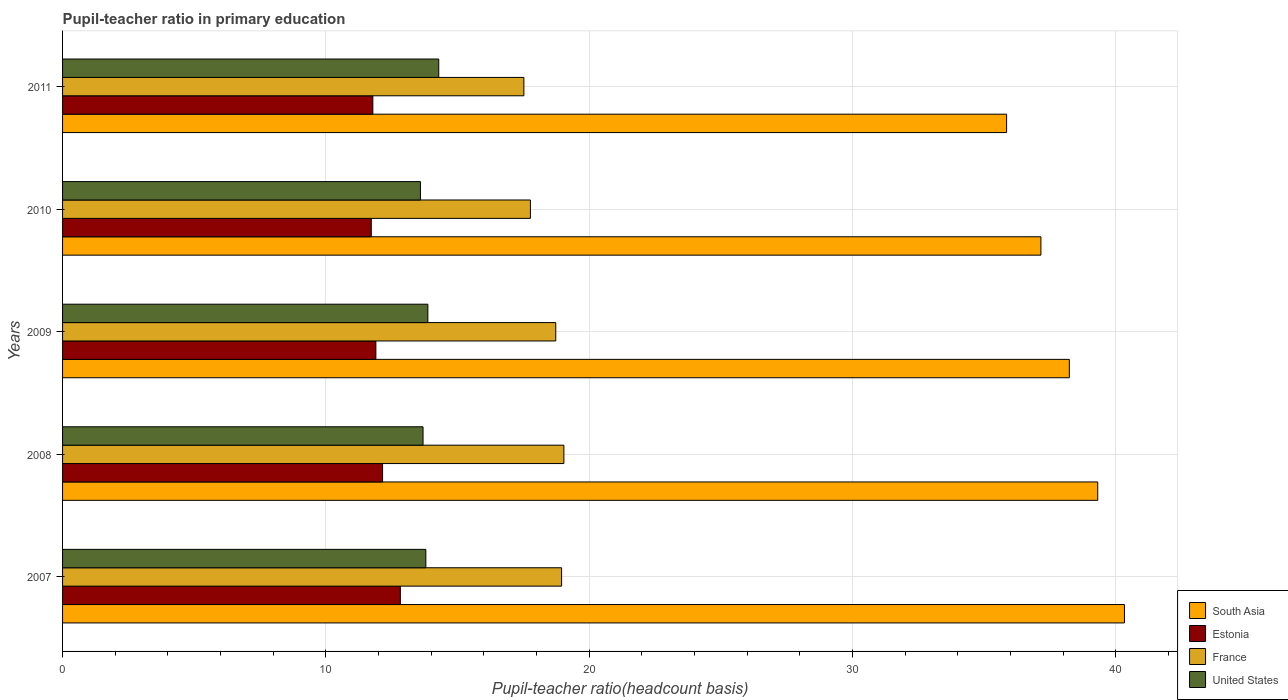How many different coloured bars are there?
Make the answer very short. 4. How many bars are there on the 4th tick from the top?
Ensure brevity in your answer.  4. How many bars are there on the 2nd tick from the bottom?
Ensure brevity in your answer.  4. In how many cases, is the number of bars for a given year not equal to the number of legend labels?
Offer a terse response. 0. What is the pupil-teacher ratio in primary education in Estonia in 2008?
Make the answer very short. 12.15. Across all years, what is the maximum pupil-teacher ratio in primary education in South Asia?
Your answer should be very brief. 40.33. Across all years, what is the minimum pupil-teacher ratio in primary education in South Asia?
Your answer should be compact. 35.85. In which year was the pupil-teacher ratio in primary education in South Asia minimum?
Make the answer very short. 2011. What is the total pupil-teacher ratio in primary education in South Asia in the graph?
Your answer should be compact. 190.87. What is the difference between the pupil-teacher ratio in primary education in South Asia in 2007 and that in 2010?
Provide a short and direct response. 3.17. What is the difference between the pupil-teacher ratio in primary education in France in 2010 and the pupil-teacher ratio in primary education in Estonia in 2011?
Ensure brevity in your answer.  5.98. What is the average pupil-teacher ratio in primary education in United States per year?
Your response must be concise. 13.85. In the year 2007, what is the difference between the pupil-teacher ratio in primary education in South Asia and pupil-teacher ratio in primary education in United States?
Keep it short and to the point. 26.53. What is the ratio of the pupil-teacher ratio in primary education in France in 2010 to that in 2011?
Provide a short and direct response. 1.01. Is the difference between the pupil-teacher ratio in primary education in South Asia in 2007 and 2011 greater than the difference between the pupil-teacher ratio in primary education in United States in 2007 and 2011?
Offer a terse response. Yes. What is the difference between the highest and the second highest pupil-teacher ratio in primary education in South Asia?
Your answer should be compact. 1.02. What is the difference between the highest and the lowest pupil-teacher ratio in primary education in France?
Give a very brief answer. 1.52. In how many years, is the pupil-teacher ratio in primary education in France greater than the average pupil-teacher ratio in primary education in France taken over all years?
Your answer should be very brief. 3. Is the sum of the pupil-teacher ratio in primary education in France in 2010 and 2011 greater than the maximum pupil-teacher ratio in primary education in Estonia across all years?
Make the answer very short. Yes. Is it the case that in every year, the sum of the pupil-teacher ratio in primary education in Estonia and pupil-teacher ratio in primary education in France is greater than the sum of pupil-teacher ratio in primary education in South Asia and pupil-teacher ratio in primary education in United States?
Offer a very short reply. Yes. What does the 2nd bar from the top in 2011 represents?
Give a very brief answer. France. What does the 3rd bar from the bottom in 2011 represents?
Provide a short and direct response. France. Is it the case that in every year, the sum of the pupil-teacher ratio in primary education in United States and pupil-teacher ratio in primary education in France is greater than the pupil-teacher ratio in primary education in Estonia?
Offer a terse response. Yes. How many bars are there?
Your answer should be very brief. 20. Are all the bars in the graph horizontal?
Keep it short and to the point. Yes. How many years are there in the graph?
Your answer should be compact. 5. Does the graph contain any zero values?
Make the answer very short. No. How many legend labels are there?
Provide a short and direct response. 4. How are the legend labels stacked?
Provide a succinct answer. Vertical. What is the title of the graph?
Your answer should be compact. Pupil-teacher ratio in primary education. What is the label or title of the X-axis?
Ensure brevity in your answer.  Pupil-teacher ratio(headcount basis). What is the Pupil-teacher ratio(headcount basis) in South Asia in 2007?
Keep it short and to the point. 40.33. What is the Pupil-teacher ratio(headcount basis) of Estonia in 2007?
Your answer should be very brief. 12.83. What is the Pupil-teacher ratio(headcount basis) in France in 2007?
Your answer should be compact. 18.95. What is the Pupil-teacher ratio(headcount basis) of United States in 2007?
Ensure brevity in your answer.  13.8. What is the Pupil-teacher ratio(headcount basis) of South Asia in 2008?
Give a very brief answer. 39.31. What is the Pupil-teacher ratio(headcount basis) in Estonia in 2008?
Keep it short and to the point. 12.15. What is the Pupil-teacher ratio(headcount basis) in France in 2008?
Ensure brevity in your answer.  19.04. What is the Pupil-teacher ratio(headcount basis) in United States in 2008?
Your answer should be compact. 13.69. What is the Pupil-teacher ratio(headcount basis) of South Asia in 2009?
Provide a succinct answer. 38.23. What is the Pupil-teacher ratio(headcount basis) of Estonia in 2009?
Ensure brevity in your answer.  11.9. What is the Pupil-teacher ratio(headcount basis) of France in 2009?
Your answer should be compact. 18.73. What is the Pupil-teacher ratio(headcount basis) in United States in 2009?
Your answer should be very brief. 13.87. What is the Pupil-teacher ratio(headcount basis) of South Asia in 2010?
Offer a terse response. 37.15. What is the Pupil-teacher ratio(headcount basis) in Estonia in 2010?
Provide a short and direct response. 11.72. What is the Pupil-teacher ratio(headcount basis) of France in 2010?
Ensure brevity in your answer.  17.77. What is the Pupil-teacher ratio(headcount basis) of United States in 2010?
Offer a terse response. 13.59. What is the Pupil-teacher ratio(headcount basis) of South Asia in 2011?
Your answer should be compact. 35.85. What is the Pupil-teacher ratio(headcount basis) in Estonia in 2011?
Ensure brevity in your answer.  11.78. What is the Pupil-teacher ratio(headcount basis) in France in 2011?
Provide a short and direct response. 17.52. What is the Pupil-teacher ratio(headcount basis) in United States in 2011?
Ensure brevity in your answer.  14.29. Across all years, what is the maximum Pupil-teacher ratio(headcount basis) in South Asia?
Your answer should be very brief. 40.33. Across all years, what is the maximum Pupil-teacher ratio(headcount basis) of Estonia?
Provide a short and direct response. 12.83. Across all years, what is the maximum Pupil-teacher ratio(headcount basis) of France?
Your response must be concise. 19.04. Across all years, what is the maximum Pupil-teacher ratio(headcount basis) in United States?
Your answer should be very brief. 14.29. Across all years, what is the minimum Pupil-teacher ratio(headcount basis) of South Asia?
Provide a succinct answer. 35.85. Across all years, what is the minimum Pupil-teacher ratio(headcount basis) in Estonia?
Ensure brevity in your answer.  11.72. Across all years, what is the minimum Pupil-teacher ratio(headcount basis) in France?
Your answer should be compact. 17.52. Across all years, what is the minimum Pupil-teacher ratio(headcount basis) in United States?
Keep it short and to the point. 13.59. What is the total Pupil-teacher ratio(headcount basis) of South Asia in the graph?
Give a very brief answer. 190.87. What is the total Pupil-teacher ratio(headcount basis) in Estonia in the graph?
Keep it short and to the point. 60.38. What is the total Pupil-teacher ratio(headcount basis) of France in the graph?
Give a very brief answer. 92. What is the total Pupil-teacher ratio(headcount basis) of United States in the graph?
Provide a short and direct response. 69.23. What is the difference between the Pupil-teacher ratio(headcount basis) of South Asia in 2007 and that in 2008?
Make the answer very short. 1.02. What is the difference between the Pupil-teacher ratio(headcount basis) in Estonia in 2007 and that in 2008?
Keep it short and to the point. 0.67. What is the difference between the Pupil-teacher ratio(headcount basis) of France in 2007 and that in 2008?
Provide a succinct answer. -0.09. What is the difference between the Pupil-teacher ratio(headcount basis) in United States in 2007 and that in 2008?
Offer a terse response. 0.11. What is the difference between the Pupil-teacher ratio(headcount basis) in South Asia in 2007 and that in 2009?
Ensure brevity in your answer.  2.09. What is the difference between the Pupil-teacher ratio(headcount basis) of Estonia in 2007 and that in 2009?
Offer a very short reply. 0.93. What is the difference between the Pupil-teacher ratio(headcount basis) of France in 2007 and that in 2009?
Make the answer very short. 0.22. What is the difference between the Pupil-teacher ratio(headcount basis) in United States in 2007 and that in 2009?
Provide a succinct answer. -0.08. What is the difference between the Pupil-teacher ratio(headcount basis) in South Asia in 2007 and that in 2010?
Your response must be concise. 3.17. What is the difference between the Pupil-teacher ratio(headcount basis) in Estonia in 2007 and that in 2010?
Provide a succinct answer. 1.1. What is the difference between the Pupil-teacher ratio(headcount basis) in France in 2007 and that in 2010?
Your response must be concise. 1.18. What is the difference between the Pupil-teacher ratio(headcount basis) of United States in 2007 and that in 2010?
Offer a very short reply. 0.2. What is the difference between the Pupil-teacher ratio(headcount basis) of South Asia in 2007 and that in 2011?
Provide a short and direct response. 4.48. What is the difference between the Pupil-teacher ratio(headcount basis) of Estonia in 2007 and that in 2011?
Your answer should be compact. 1.04. What is the difference between the Pupil-teacher ratio(headcount basis) in France in 2007 and that in 2011?
Offer a very short reply. 1.43. What is the difference between the Pupil-teacher ratio(headcount basis) in United States in 2007 and that in 2011?
Your response must be concise. -0.49. What is the difference between the Pupil-teacher ratio(headcount basis) of South Asia in 2008 and that in 2009?
Offer a very short reply. 1.08. What is the difference between the Pupil-teacher ratio(headcount basis) of Estonia in 2008 and that in 2009?
Give a very brief answer. 0.26. What is the difference between the Pupil-teacher ratio(headcount basis) in France in 2008 and that in 2009?
Provide a short and direct response. 0.31. What is the difference between the Pupil-teacher ratio(headcount basis) in United States in 2008 and that in 2009?
Provide a short and direct response. -0.18. What is the difference between the Pupil-teacher ratio(headcount basis) of South Asia in 2008 and that in 2010?
Offer a terse response. 2.16. What is the difference between the Pupil-teacher ratio(headcount basis) in Estonia in 2008 and that in 2010?
Offer a terse response. 0.43. What is the difference between the Pupil-teacher ratio(headcount basis) of France in 2008 and that in 2010?
Keep it short and to the point. 1.27. What is the difference between the Pupil-teacher ratio(headcount basis) in United States in 2008 and that in 2010?
Ensure brevity in your answer.  0.1. What is the difference between the Pupil-teacher ratio(headcount basis) in South Asia in 2008 and that in 2011?
Your answer should be compact. 3.46. What is the difference between the Pupil-teacher ratio(headcount basis) in Estonia in 2008 and that in 2011?
Provide a short and direct response. 0.37. What is the difference between the Pupil-teacher ratio(headcount basis) in France in 2008 and that in 2011?
Make the answer very short. 1.52. What is the difference between the Pupil-teacher ratio(headcount basis) of United States in 2008 and that in 2011?
Offer a terse response. -0.6. What is the difference between the Pupil-teacher ratio(headcount basis) of South Asia in 2009 and that in 2010?
Make the answer very short. 1.08. What is the difference between the Pupil-teacher ratio(headcount basis) in Estonia in 2009 and that in 2010?
Your answer should be very brief. 0.17. What is the difference between the Pupil-teacher ratio(headcount basis) of France in 2009 and that in 2010?
Make the answer very short. 0.96. What is the difference between the Pupil-teacher ratio(headcount basis) in United States in 2009 and that in 2010?
Ensure brevity in your answer.  0.28. What is the difference between the Pupil-teacher ratio(headcount basis) of South Asia in 2009 and that in 2011?
Provide a short and direct response. 2.38. What is the difference between the Pupil-teacher ratio(headcount basis) of Estonia in 2009 and that in 2011?
Offer a terse response. 0.11. What is the difference between the Pupil-teacher ratio(headcount basis) of France in 2009 and that in 2011?
Give a very brief answer. 1.21. What is the difference between the Pupil-teacher ratio(headcount basis) of United States in 2009 and that in 2011?
Keep it short and to the point. -0.41. What is the difference between the Pupil-teacher ratio(headcount basis) in South Asia in 2010 and that in 2011?
Your answer should be very brief. 1.3. What is the difference between the Pupil-teacher ratio(headcount basis) of Estonia in 2010 and that in 2011?
Your response must be concise. -0.06. What is the difference between the Pupil-teacher ratio(headcount basis) in France in 2010 and that in 2011?
Your answer should be very brief. 0.25. What is the difference between the Pupil-teacher ratio(headcount basis) of United States in 2010 and that in 2011?
Your response must be concise. -0.69. What is the difference between the Pupil-teacher ratio(headcount basis) of South Asia in 2007 and the Pupil-teacher ratio(headcount basis) of Estonia in 2008?
Provide a succinct answer. 28.17. What is the difference between the Pupil-teacher ratio(headcount basis) of South Asia in 2007 and the Pupil-teacher ratio(headcount basis) of France in 2008?
Make the answer very short. 21.29. What is the difference between the Pupil-teacher ratio(headcount basis) of South Asia in 2007 and the Pupil-teacher ratio(headcount basis) of United States in 2008?
Give a very brief answer. 26.64. What is the difference between the Pupil-teacher ratio(headcount basis) of Estonia in 2007 and the Pupil-teacher ratio(headcount basis) of France in 2008?
Ensure brevity in your answer.  -6.21. What is the difference between the Pupil-teacher ratio(headcount basis) of Estonia in 2007 and the Pupil-teacher ratio(headcount basis) of United States in 2008?
Your response must be concise. -0.86. What is the difference between the Pupil-teacher ratio(headcount basis) in France in 2007 and the Pupil-teacher ratio(headcount basis) in United States in 2008?
Make the answer very short. 5.26. What is the difference between the Pupil-teacher ratio(headcount basis) in South Asia in 2007 and the Pupil-teacher ratio(headcount basis) in Estonia in 2009?
Ensure brevity in your answer.  28.43. What is the difference between the Pupil-teacher ratio(headcount basis) of South Asia in 2007 and the Pupil-teacher ratio(headcount basis) of France in 2009?
Offer a terse response. 21.6. What is the difference between the Pupil-teacher ratio(headcount basis) of South Asia in 2007 and the Pupil-teacher ratio(headcount basis) of United States in 2009?
Offer a terse response. 26.45. What is the difference between the Pupil-teacher ratio(headcount basis) in Estonia in 2007 and the Pupil-teacher ratio(headcount basis) in France in 2009?
Ensure brevity in your answer.  -5.9. What is the difference between the Pupil-teacher ratio(headcount basis) in Estonia in 2007 and the Pupil-teacher ratio(headcount basis) in United States in 2009?
Provide a succinct answer. -1.05. What is the difference between the Pupil-teacher ratio(headcount basis) of France in 2007 and the Pupil-teacher ratio(headcount basis) of United States in 2009?
Keep it short and to the point. 5.08. What is the difference between the Pupil-teacher ratio(headcount basis) of South Asia in 2007 and the Pupil-teacher ratio(headcount basis) of Estonia in 2010?
Make the answer very short. 28.6. What is the difference between the Pupil-teacher ratio(headcount basis) of South Asia in 2007 and the Pupil-teacher ratio(headcount basis) of France in 2010?
Your answer should be compact. 22.56. What is the difference between the Pupil-teacher ratio(headcount basis) in South Asia in 2007 and the Pupil-teacher ratio(headcount basis) in United States in 2010?
Offer a very short reply. 26.73. What is the difference between the Pupil-teacher ratio(headcount basis) in Estonia in 2007 and the Pupil-teacher ratio(headcount basis) in France in 2010?
Provide a succinct answer. -4.94. What is the difference between the Pupil-teacher ratio(headcount basis) in Estonia in 2007 and the Pupil-teacher ratio(headcount basis) in United States in 2010?
Your answer should be compact. -0.76. What is the difference between the Pupil-teacher ratio(headcount basis) of France in 2007 and the Pupil-teacher ratio(headcount basis) of United States in 2010?
Give a very brief answer. 5.36. What is the difference between the Pupil-teacher ratio(headcount basis) of South Asia in 2007 and the Pupil-teacher ratio(headcount basis) of Estonia in 2011?
Your answer should be compact. 28.54. What is the difference between the Pupil-teacher ratio(headcount basis) in South Asia in 2007 and the Pupil-teacher ratio(headcount basis) in France in 2011?
Provide a short and direct response. 22.81. What is the difference between the Pupil-teacher ratio(headcount basis) of South Asia in 2007 and the Pupil-teacher ratio(headcount basis) of United States in 2011?
Make the answer very short. 26.04. What is the difference between the Pupil-teacher ratio(headcount basis) in Estonia in 2007 and the Pupil-teacher ratio(headcount basis) in France in 2011?
Offer a terse response. -4.69. What is the difference between the Pupil-teacher ratio(headcount basis) in Estonia in 2007 and the Pupil-teacher ratio(headcount basis) in United States in 2011?
Offer a terse response. -1.46. What is the difference between the Pupil-teacher ratio(headcount basis) in France in 2007 and the Pupil-teacher ratio(headcount basis) in United States in 2011?
Make the answer very short. 4.66. What is the difference between the Pupil-teacher ratio(headcount basis) of South Asia in 2008 and the Pupil-teacher ratio(headcount basis) of Estonia in 2009?
Make the answer very short. 27.41. What is the difference between the Pupil-teacher ratio(headcount basis) of South Asia in 2008 and the Pupil-teacher ratio(headcount basis) of France in 2009?
Offer a terse response. 20.58. What is the difference between the Pupil-teacher ratio(headcount basis) in South Asia in 2008 and the Pupil-teacher ratio(headcount basis) in United States in 2009?
Your answer should be very brief. 25.44. What is the difference between the Pupil-teacher ratio(headcount basis) in Estonia in 2008 and the Pupil-teacher ratio(headcount basis) in France in 2009?
Make the answer very short. -6.58. What is the difference between the Pupil-teacher ratio(headcount basis) in Estonia in 2008 and the Pupil-teacher ratio(headcount basis) in United States in 2009?
Offer a terse response. -1.72. What is the difference between the Pupil-teacher ratio(headcount basis) in France in 2008 and the Pupil-teacher ratio(headcount basis) in United States in 2009?
Provide a short and direct response. 5.17. What is the difference between the Pupil-teacher ratio(headcount basis) of South Asia in 2008 and the Pupil-teacher ratio(headcount basis) of Estonia in 2010?
Keep it short and to the point. 27.59. What is the difference between the Pupil-teacher ratio(headcount basis) in South Asia in 2008 and the Pupil-teacher ratio(headcount basis) in France in 2010?
Ensure brevity in your answer.  21.54. What is the difference between the Pupil-teacher ratio(headcount basis) of South Asia in 2008 and the Pupil-teacher ratio(headcount basis) of United States in 2010?
Your answer should be very brief. 25.72. What is the difference between the Pupil-teacher ratio(headcount basis) in Estonia in 2008 and the Pupil-teacher ratio(headcount basis) in France in 2010?
Offer a very short reply. -5.61. What is the difference between the Pupil-teacher ratio(headcount basis) in Estonia in 2008 and the Pupil-teacher ratio(headcount basis) in United States in 2010?
Give a very brief answer. -1.44. What is the difference between the Pupil-teacher ratio(headcount basis) in France in 2008 and the Pupil-teacher ratio(headcount basis) in United States in 2010?
Provide a succinct answer. 5.45. What is the difference between the Pupil-teacher ratio(headcount basis) in South Asia in 2008 and the Pupil-teacher ratio(headcount basis) in Estonia in 2011?
Your answer should be compact. 27.53. What is the difference between the Pupil-teacher ratio(headcount basis) of South Asia in 2008 and the Pupil-teacher ratio(headcount basis) of France in 2011?
Keep it short and to the point. 21.79. What is the difference between the Pupil-teacher ratio(headcount basis) of South Asia in 2008 and the Pupil-teacher ratio(headcount basis) of United States in 2011?
Your answer should be very brief. 25.02. What is the difference between the Pupil-teacher ratio(headcount basis) in Estonia in 2008 and the Pupil-teacher ratio(headcount basis) in France in 2011?
Your response must be concise. -5.37. What is the difference between the Pupil-teacher ratio(headcount basis) in Estonia in 2008 and the Pupil-teacher ratio(headcount basis) in United States in 2011?
Make the answer very short. -2.13. What is the difference between the Pupil-teacher ratio(headcount basis) of France in 2008 and the Pupil-teacher ratio(headcount basis) of United States in 2011?
Your response must be concise. 4.75. What is the difference between the Pupil-teacher ratio(headcount basis) in South Asia in 2009 and the Pupil-teacher ratio(headcount basis) in Estonia in 2010?
Keep it short and to the point. 26.51. What is the difference between the Pupil-teacher ratio(headcount basis) in South Asia in 2009 and the Pupil-teacher ratio(headcount basis) in France in 2010?
Provide a succinct answer. 20.47. What is the difference between the Pupil-teacher ratio(headcount basis) in South Asia in 2009 and the Pupil-teacher ratio(headcount basis) in United States in 2010?
Give a very brief answer. 24.64. What is the difference between the Pupil-teacher ratio(headcount basis) of Estonia in 2009 and the Pupil-teacher ratio(headcount basis) of France in 2010?
Make the answer very short. -5.87. What is the difference between the Pupil-teacher ratio(headcount basis) of Estonia in 2009 and the Pupil-teacher ratio(headcount basis) of United States in 2010?
Provide a succinct answer. -1.69. What is the difference between the Pupil-teacher ratio(headcount basis) in France in 2009 and the Pupil-teacher ratio(headcount basis) in United States in 2010?
Provide a succinct answer. 5.14. What is the difference between the Pupil-teacher ratio(headcount basis) in South Asia in 2009 and the Pupil-teacher ratio(headcount basis) in Estonia in 2011?
Give a very brief answer. 26.45. What is the difference between the Pupil-teacher ratio(headcount basis) in South Asia in 2009 and the Pupil-teacher ratio(headcount basis) in France in 2011?
Offer a terse response. 20.71. What is the difference between the Pupil-teacher ratio(headcount basis) of South Asia in 2009 and the Pupil-teacher ratio(headcount basis) of United States in 2011?
Your answer should be very brief. 23.95. What is the difference between the Pupil-teacher ratio(headcount basis) of Estonia in 2009 and the Pupil-teacher ratio(headcount basis) of France in 2011?
Your answer should be compact. -5.62. What is the difference between the Pupil-teacher ratio(headcount basis) of Estonia in 2009 and the Pupil-teacher ratio(headcount basis) of United States in 2011?
Your answer should be very brief. -2.39. What is the difference between the Pupil-teacher ratio(headcount basis) of France in 2009 and the Pupil-teacher ratio(headcount basis) of United States in 2011?
Keep it short and to the point. 4.44. What is the difference between the Pupil-teacher ratio(headcount basis) of South Asia in 2010 and the Pupil-teacher ratio(headcount basis) of Estonia in 2011?
Ensure brevity in your answer.  25.37. What is the difference between the Pupil-teacher ratio(headcount basis) of South Asia in 2010 and the Pupil-teacher ratio(headcount basis) of France in 2011?
Provide a succinct answer. 19.63. What is the difference between the Pupil-teacher ratio(headcount basis) in South Asia in 2010 and the Pupil-teacher ratio(headcount basis) in United States in 2011?
Ensure brevity in your answer.  22.87. What is the difference between the Pupil-teacher ratio(headcount basis) in Estonia in 2010 and the Pupil-teacher ratio(headcount basis) in France in 2011?
Give a very brief answer. -5.79. What is the difference between the Pupil-teacher ratio(headcount basis) of Estonia in 2010 and the Pupil-teacher ratio(headcount basis) of United States in 2011?
Your response must be concise. -2.56. What is the difference between the Pupil-teacher ratio(headcount basis) of France in 2010 and the Pupil-teacher ratio(headcount basis) of United States in 2011?
Provide a short and direct response. 3.48. What is the average Pupil-teacher ratio(headcount basis) in South Asia per year?
Provide a short and direct response. 38.17. What is the average Pupil-teacher ratio(headcount basis) in Estonia per year?
Give a very brief answer. 12.08. What is the average Pupil-teacher ratio(headcount basis) in France per year?
Your answer should be compact. 18.4. What is the average Pupil-teacher ratio(headcount basis) in United States per year?
Keep it short and to the point. 13.85. In the year 2007, what is the difference between the Pupil-teacher ratio(headcount basis) of South Asia and Pupil-teacher ratio(headcount basis) of Estonia?
Offer a very short reply. 27.5. In the year 2007, what is the difference between the Pupil-teacher ratio(headcount basis) in South Asia and Pupil-teacher ratio(headcount basis) in France?
Provide a short and direct response. 21.38. In the year 2007, what is the difference between the Pupil-teacher ratio(headcount basis) of South Asia and Pupil-teacher ratio(headcount basis) of United States?
Give a very brief answer. 26.53. In the year 2007, what is the difference between the Pupil-teacher ratio(headcount basis) of Estonia and Pupil-teacher ratio(headcount basis) of France?
Your answer should be compact. -6.12. In the year 2007, what is the difference between the Pupil-teacher ratio(headcount basis) of Estonia and Pupil-teacher ratio(headcount basis) of United States?
Your answer should be very brief. -0.97. In the year 2007, what is the difference between the Pupil-teacher ratio(headcount basis) in France and Pupil-teacher ratio(headcount basis) in United States?
Your response must be concise. 5.15. In the year 2008, what is the difference between the Pupil-teacher ratio(headcount basis) in South Asia and Pupil-teacher ratio(headcount basis) in Estonia?
Offer a terse response. 27.16. In the year 2008, what is the difference between the Pupil-teacher ratio(headcount basis) of South Asia and Pupil-teacher ratio(headcount basis) of France?
Your answer should be very brief. 20.27. In the year 2008, what is the difference between the Pupil-teacher ratio(headcount basis) in South Asia and Pupil-teacher ratio(headcount basis) in United States?
Keep it short and to the point. 25.62. In the year 2008, what is the difference between the Pupil-teacher ratio(headcount basis) of Estonia and Pupil-teacher ratio(headcount basis) of France?
Offer a very short reply. -6.88. In the year 2008, what is the difference between the Pupil-teacher ratio(headcount basis) in Estonia and Pupil-teacher ratio(headcount basis) in United States?
Your answer should be very brief. -1.54. In the year 2008, what is the difference between the Pupil-teacher ratio(headcount basis) in France and Pupil-teacher ratio(headcount basis) in United States?
Offer a very short reply. 5.35. In the year 2009, what is the difference between the Pupil-teacher ratio(headcount basis) in South Asia and Pupil-teacher ratio(headcount basis) in Estonia?
Your answer should be very brief. 26.33. In the year 2009, what is the difference between the Pupil-teacher ratio(headcount basis) of South Asia and Pupil-teacher ratio(headcount basis) of France?
Your answer should be very brief. 19.5. In the year 2009, what is the difference between the Pupil-teacher ratio(headcount basis) of South Asia and Pupil-teacher ratio(headcount basis) of United States?
Your response must be concise. 24.36. In the year 2009, what is the difference between the Pupil-teacher ratio(headcount basis) of Estonia and Pupil-teacher ratio(headcount basis) of France?
Make the answer very short. -6.83. In the year 2009, what is the difference between the Pupil-teacher ratio(headcount basis) in Estonia and Pupil-teacher ratio(headcount basis) in United States?
Offer a terse response. -1.97. In the year 2009, what is the difference between the Pupil-teacher ratio(headcount basis) of France and Pupil-teacher ratio(headcount basis) of United States?
Offer a terse response. 4.86. In the year 2010, what is the difference between the Pupil-teacher ratio(headcount basis) of South Asia and Pupil-teacher ratio(headcount basis) of Estonia?
Offer a terse response. 25.43. In the year 2010, what is the difference between the Pupil-teacher ratio(headcount basis) of South Asia and Pupil-teacher ratio(headcount basis) of France?
Provide a succinct answer. 19.39. In the year 2010, what is the difference between the Pupil-teacher ratio(headcount basis) of South Asia and Pupil-teacher ratio(headcount basis) of United States?
Provide a succinct answer. 23.56. In the year 2010, what is the difference between the Pupil-teacher ratio(headcount basis) of Estonia and Pupil-teacher ratio(headcount basis) of France?
Keep it short and to the point. -6.04. In the year 2010, what is the difference between the Pupil-teacher ratio(headcount basis) in Estonia and Pupil-teacher ratio(headcount basis) in United States?
Keep it short and to the point. -1.87. In the year 2010, what is the difference between the Pupil-teacher ratio(headcount basis) in France and Pupil-teacher ratio(headcount basis) in United States?
Provide a succinct answer. 4.18. In the year 2011, what is the difference between the Pupil-teacher ratio(headcount basis) in South Asia and Pupil-teacher ratio(headcount basis) in Estonia?
Provide a short and direct response. 24.07. In the year 2011, what is the difference between the Pupil-teacher ratio(headcount basis) of South Asia and Pupil-teacher ratio(headcount basis) of France?
Give a very brief answer. 18.33. In the year 2011, what is the difference between the Pupil-teacher ratio(headcount basis) in South Asia and Pupil-teacher ratio(headcount basis) in United States?
Make the answer very short. 21.56. In the year 2011, what is the difference between the Pupil-teacher ratio(headcount basis) of Estonia and Pupil-teacher ratio(headcount basis) of France?
Give a very brief answer. -5.74. In the year 2011, what is the difference between the Pupil-teacher ratio(headcount basis) in Estonia and Pupil-teacher ratio(headcount basis) in United States?
Offer a terse response. -2.5. In the year 2011, what is the difference between the Pupil-teacher ratio(headcount basis) in France and Pupil-teacher ratio(headcount basis) in United States?
Keep it short and to the point. 3.23. What is the ratio of the Pupil-teacher ratio(headcount basis) in South Asia in 2007 to that in 2008?
Offer a terse response. 1.03. What is the ratio of the Pupil-teacher ratio(headcount basis) in Estonia in 2007 to that in 2008?
Give a very brief answer. 1.06. What is the ratio of the Pupil-teacher ratio(headcount basis) in France in 2007 to that in 2008?
Offer a terse response. 1. What is the ratio of the Pupil-teacher ratio(headcount basis) in South Asia in 2007 to that in 2009?
Offer a terse response. 1.05. What is the ratio of the Pupil-teacher ratio(headcount basis) in Estonia in 2007 to that in 2009?
Your response must be concise. 1.08. What is the ratio of the Pupil-teacher ratio(headcount basis) in France in 2007 to that in 2009?
Ensure brevity in your answer.  1.01. What is the ratio of the Pupil-teacher ratio(headcount basis) of United States in 2007 to that in 2009?
Your answer should be compact. 0.99. What is the ratio of the Pupil-teacher ratio(headcount basis) of South Asia in 2007 to that in 2010?
Offer a very short reply. 1.09. What is the ratio of the Pupil-teacher ratio(headcount basis) of Estonia in 2007 to that in 2010?
Your response must be concise. 1.09. What is the ratio of the Pupil-teacher ratio(headcount basis) in France in 2007 to that in 2010?
Your answer should be compact. 1.07. What is the ratio of the Pupil-teacher ratio(headcount basis) of United States in 2007 to that in 2010?
Your response must be concise. 1.02. What is the ratio of the Pupil-teacher ratio(headcount basis) of South Asia in 2007 to that in 2011?
Provide a short and direct response. 1.12. What is the ratio of the Pupil-teacher ratio(headcount basis) in Estonia in 2007 to that in 2011?
Offer a very short reply. 1.09. What is the ratio of the Pupil-teacher ratio(headcount basis) of France in 2007 to that in 2011?
Provide a short and direct response. 1.08. What is the ratio of the Pupil-teacher ratio(headcount basis) in United States in 2007 to that in 2011?
Give a very brief answer. 0.97. What is the ratio of the Pupil-teacher ratio(headcount basis) in South Asia in 2008 to that in 2009?
Give a very brief answer. 1.03. What is the ratio of the Pupil-teacher ratio(headcount basis) in Estonia in 2008 to that in 2009?
Provide a short and direct response. 1.02. What is the ratio of the Pupil-teacher ratio(headcount basis) of France in 2008 to that in 2009?
Provide a short and direct response. 1.02. What is the ratio of the Pupil-teacher ratio(headcount basis) of South Asia in 2008 to that in 2010?
Offer a terse response. 1.06. What is the ratio of the Pupil-teacher ratio(headcount basis) of Estonia in 2008 to that in 2010?
Keep it short and to the point. 1.04. What is the ratio of the Pupil-teacher ratio(headcount basis) of France in 2008 to that in 2010?
Your response must be concise. 1.07. What is the ratio of the Pupil-teacher ratio(headcount basis) in South Asia in 2008 to that in 2011?
Make the answer very short. 1.1. What is the ratio of the Pupil-teacher ratio(headcount basis) in Estonia in 2008 to that in 2011?
Your response must be concise. 1.03. What is the ratio of the Pupil-teacher ratio(headcount basis) of France in 2008 to that in 2011?
Make the answer very short. 1.09. What is the ratio of the Pupil-teacher ratio(headcount basis) in South Asia in 2009 to that in 2010?
Make the answer very short. 1.03. What is the ratio of the Pupil-teacher ratio(headcount basis) in Estonia in 2009 to that in 2010?
Ensure brevity in your answer.  1.01. What is the ratio of the Pupil-teacher ratio(headcount basis) in France in 2009 to that in 2010?
Ensure brevity in your answer.  1.05. What is the ratio of the Pupil-teacher ratio(headcount basis) in United States in 2009 to that in 2010?
Ensure brevity in your answer.  1.02. What is the ratio of the Pupil-teacher ratio(headcount basis) of South Asia in 2009 to that in 2011?
Offer a very short reply. 1.07. What is the ratio of the Pupil-teacher ratio(headcount basis) of Estonia in 2009 to that in 2011?
Your answer should be compact. 1.01. What is the ratio of the Pupil-teacher ratio(headcount basis) in France in 2009 to that in 2011?
Your answer should be very brief. 1.07. What is the ratio of the Pupil-teacher ratio(headcount basis) of United States in 2009 to that in 2011?
Your answer should be compact. 0.97. What is the ratio of the Pupil-teacher ratio(headcount basis) of South Asia in 2010 to that in 2011?
Make the answer very short. 1.04. What is the ratio of the Pupil-teacher ratio(headcount basis) of France in 2010 to that in 2011?
Keep it short and to the point. 1.01. What is the ratio of the Pupil-teacher ratio(headcount basis) of United States in 2010 to that in 2011?
Your response must be concise. 0.95. What is the difference between the highest and the second highest Pupil-teacher ratio(headcount basis) in South Asia?
Ensure brevity in your answer.  1.02. What is the difference between the highest and the second highest Pupil-teacher ratio(headcount basis) of Estonia?
Offer a very short reply. 0.67. What is the difference between the highest and the second highest Pupil-teacher ratio(headcount basis) in France?
Provide a short and direct response. 0.09. What is the difference between the highest and the second highest Pupil-teacher ratio(headcount basis) of United States?
Offer a terse response. 0.41. What is the difference between the highest and the lowest Pupil-teacher ratio(headcount basis) in South Asia?
Provide a short and direct response. 4.48. What is the difference between the highest and the lowest Pupil-teacher ratio(headcount basis) of Estonia?
Your answer should be compact. 1.1. What is the difference between the highest and the lowest Pupil-teacher ratio(headcount basis) in France?
Ensure brevity in your answer.  1.52. What is the difference between the highest and the lowest Pupil-teacher ratio(headcount basis) in United States?
Ensure brevity in your answer.  0.69. 